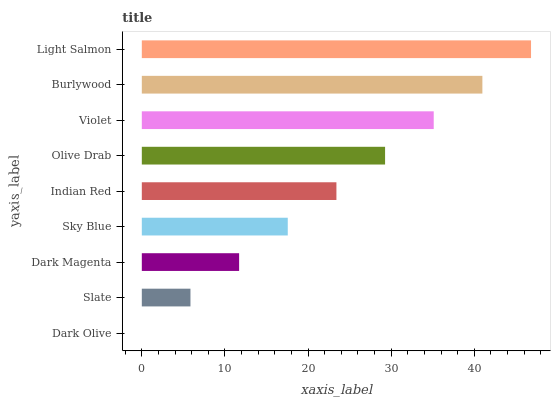Is Dark Olive the minimum?
Answer yes or no. Yes. Is Light Salmon the maximum?
Answer yes or no. Yes. Is Slate the minimum?
Answer yes or no. No. Is Slate the maximum?
Answer yes or no. No. Is Slate greater than Dark Olive?
Answer yes or no. Yes. Is Dark Olive less than Slate?
Answer yes or no. Yes. Is Dark Olive greater than Slate?
Answer yes or no. No. Is Slate less than Dark Olive?
Answer yes or no. No. Is Indian Red the high median?
Answer yes or no. Yes. Is Indian Red the low median?
Answer yes or no. Yes. Is Olive Drab the high median?
Answer yes or no. No. Is Violet the low median?
Answer yes or no. No. 